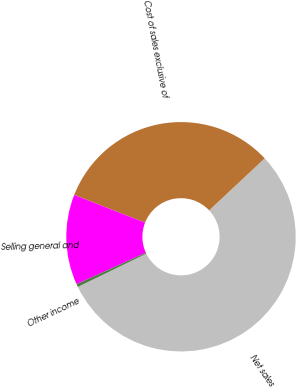Convert chart. <chart><loc_0><loc_0><loc_500><loc_500><pie_chart><fcel>Net sales<fcel>Cost of sales exclusive of<fcel>Selling general and<fcel>Other income<nl><fcel>54.79%<fcel>32.08%<fcel>12.73%<fcel>0.41%<nl></chart> 